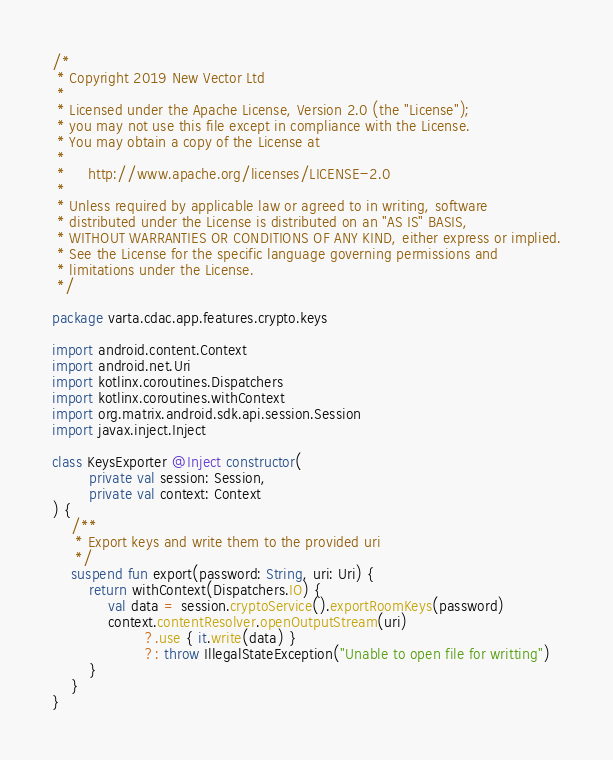<code> <loc_0><loc_0><loc_500><loc_500><_Kotlin_>/*
 * Copyright 2019 New Vector Ltd
 *
 * Licensed under the Apache License, Version 2.0 (the "License");
 * you may not use this file except in compliance with the License.
 * You may obtain a copy of the License at
 *
 *     http://www.apache.org/licenses/LICENSE-2.0
 *
 * Unless required by applicable law or agreed to in writing, software
 * distributed under the License is distributed on an "AS IS" BASIS,
 * WITHOUT WARRANTIES OR CONDITIONS OF ANY KIND, either express or implied.
 * See the License for the specific language governing permissions and
 * limitations under the License.
 */

package varta.cdac.app.features.crypto.keys

import android.content.Context
import android.net.Uri
import kotlinx.coroutines.Dispatchers
import kotlinx.coroutines.withContext
import org.matrix.android.sdk.api.session.Session
import javax.inject.Inject

class KeysExporter @Inject constructor(
        private val session: Session,
        private val context: Context
) {
    /**
     * Export keys and write them to the provided uri
     */
    suspend fun export(password: String, uri: Uri) {
        return withContext(Dispatchers.IO) {
            val data = session.cryptoService().exportRoomKeys(password)
            context.contentResolver.openOutputStream(uri)
                    ?.use { it.write(data) }
                    ?: throw IllegalStateException("Unable to open file for writting")
        }
    }
}
</code> 